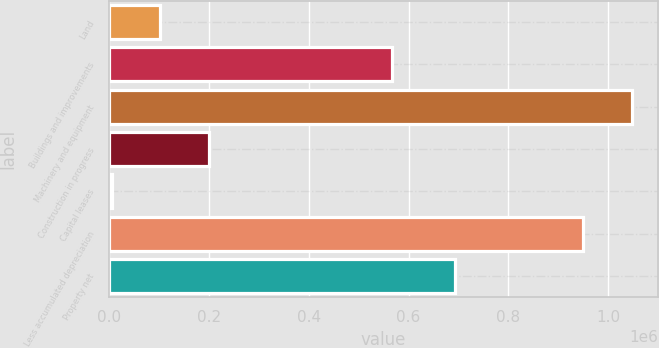Convert chart to OTSL. <chart><loc_0><loc_0><loc_500><loc_500><bar_chart><fcel>Land<fcel>Buildings and improvements<fcel>Machinery and equipment<fcel>Construction in progress<fcel>Capital leases<fcel>Less accumulated depreciation<fcel>Property net<nl><fcel>102016<fcel>566819<fcel>1.0473e+06<fcel>199271<fcel>4761<fcel>950046<fcel>692464<nl></chart> 